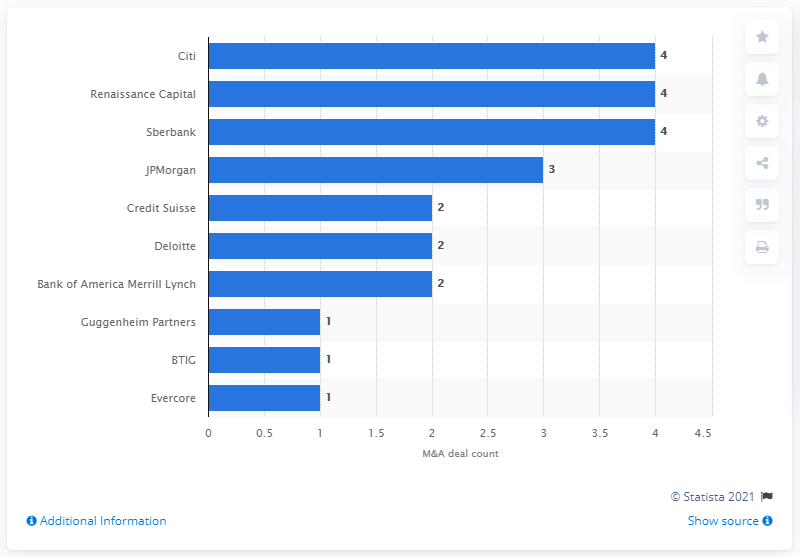Indicate a few pertinent items in this graphic. Citi emerged as the leading advisor to M&A deals in Russia in the first half of 2019. 